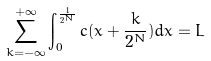Convert formula to latex. <formula><loc_0><loc_0><loc_500><loc_500>\sum _ { k = - \infty } ^ { + \infty } \int _ { 0 } ^ { \frac { 1 } { 2 ^ { N } } } { c ( x + \frac { k } { 2 ^ { N } } ) d x } = L</formula> 